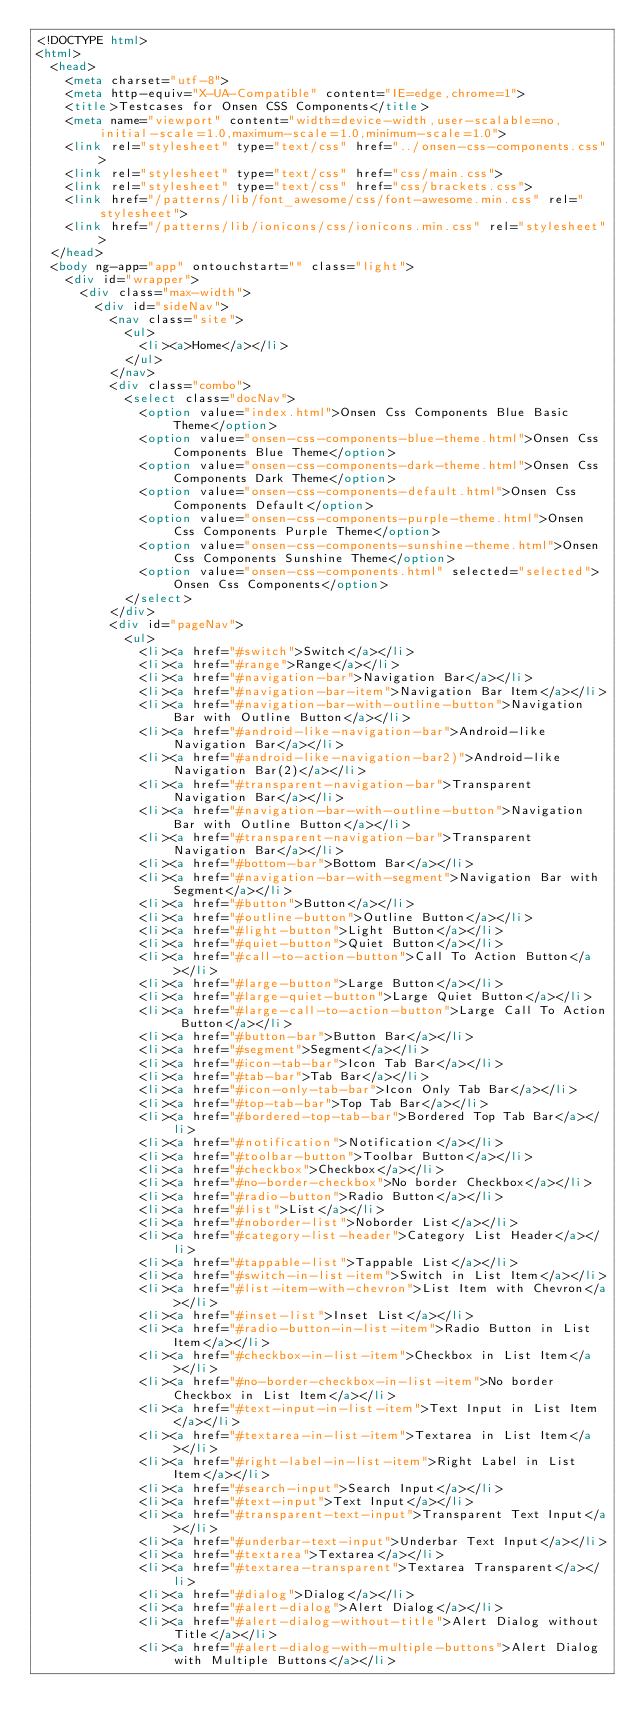<code> <loc_0><loc_0><loc_500><loc_500><_HTML_><!DOCTYPE html>
<html>
  <head>
    <meta charset="utf-8">
    <meta http-equiv="X-UA-Compatible" content="IE=edge,chrome=1">
    <title>Testcases for Onsen CSS Components</title>
    <meta name="viewport" content="width=device-width,user-scalable=no,initial-scale=1.0,maximum-scale=1.0,minimum-scale=1.0">
    <link rel="stylesheet" type="text/css" href="../onsen-css-components.css">
    <link rel="stylesheet" type="text/css" href="css/main.css">
    <link rel="stylesheet" type="text/css" href="css/brackets.css">
    <link href="/patterns/lib/font_awesome/css/font-awesome.min.css" rel="stylesheet">
    <link href="/patterns/lib/ionicons/css/ionicons.min.css" rel="stylesheet">
  </head>
  <body ng-app="app" ontouchstart="" class="light">
    <div id="wrapper">
      <div class="max-width">
        <div id="sideNav">
          <nav class="site">
            <ul>
              <li><a>Home</a></li>
            </ul>
          </nav>
          <div class="combo">
            <select class="docNav">
              <option value="index.html">Onsen Css Components Blue Basic Theme</option>
              <option value="onsen-css-components-blue-theme.html">Onsen Css Components Blue Theme</option>
              <option value="onsen-css-components-dark-theme.html">Onsen Css Components Dark Theme</option>
              <option value="onsen-css-components-default.html">Onsen Css Components Default</option>
              <option value="onsen-css-components-purple-theme.html">Onsen Css Components Purple Theme</option>
              <option value="onsen-css-components-sunshine-theme.html">Onsen Css Components Sunshine Theme</option>
              <option value="onsen-css-components.html" selected="selected">Onsen Css Components</option>
            </select>
          </div>
          <div id="pageNav">
            <ul>
              <li><a href="#switch">Switch</a></li>
              <li><a href="#range">Range</a></li>
              <li><a href="#navigation-bar">Navigation Bar</a></li>
              <li><a href="#navigation-bar-item">Navigation Bar Item</a></li>
              <li><a href="#navigation-bar-with-outline-button">Navigation Bar with Outline Button</a></li>
              <li><a href="#android-like-navigation-bar">Android-like Navigation Bar</a></li>
              <li><a href="#android-like-navigation-bar2)">Android-like Navigation Bar(2)</a></li>
              <li><a href="#transparent-navigation-bar">Transparent Navigation Bar</a></li>
              <li><a href="#navigation-bar-with-outline-button">Navigation Bar with Outline Button</a></li>
              <li><a href="#transparent-navigation-bar">Transparent Navigation Bar</a></li>
              <li><a href="#bottom-bar">Bottom Bar</a></li>
              <li><a href="#navigation-bar-with-segment">Navigation Bar with Segment</a></li>
              <li><a href="#button">Button</a></li>
              <li><a href="#outline-button">Outline Button</a></li>
              <li><a href="#light-button">Light Button</a></li>
              <li><a href="#quiet-button">Quiet Button</a></li>
              <li><a href="#call-to-action-button">Call To Action Button</a></li>
              <li><a href="#large-button">Large Button</a></li>
              <li><a href="#large-quiet-button">Large Quiet Button</a></li>
              <li><a href="#large-call-to-action-button">Large Call To Action Button</a></li>
              <li><a href="#button-bar">Button Bar</a></li>
              <li><a href="#segment">Segment</a></li>
              <li><a href="#icon-tab-bar">Icon Tab Bar</a></li>
              <li><a href="#tab-bar">Tab Bar</a></li>
              <li><a href="#icon-only-tab-bar">Icon Only Tab Bar</a></li>
              <li><a href="#top-tab-bar">Top Tab Bar</a></li>
              <li><a href="#bordered-top-tab-bar">Bordered Top Tab Bar</a></li>
              <li><a href="#notification">Notification</a></li>
              <li><a href="#toolbar-button">Toolbar Button</a></li>
              <li><a href="#checkbox">Checkbox</a></li>
              <li><a href="#no-border-checkbox">No border Checkbox</a></li>
              <li><a href="#radio-button">Radio Button</a></li>
              <li><a href="#list">List</a></li>
              <li><a href="#noborder-list">Noborder List</a></li>
              <li><a href="#category-list-header">Category List Header</a></li>
              <li><a href="#tappable-list">Tappable List</a></li>
              <li><a href="#switch-in-list-item">Switch in List Item</a></li>
              <li><a href="#list-item-with-chevron">List Item with Chevron</a></li>
              <li><a href="#inset-list">Inset List</a></li>
              <li><a href="#radio-button-in-list-item">Radio Button in List Item</a></li>
              <li><a href="#checkbox-in-list-item">Checkbox in List Item</a></li>
              <li><a href="#no-border-checkbox-in-list-item">No border Checkbox in List Item</a></li>
              <li><a href="#text-input-in-list-item">Text Input in List Item</a></li>
              <li><a href="#textarea-in-list-item">Textarea in List Item</a></li>
              <li><a href="#right-label-in-list-item">Right Label in List Item</a></li>
              <li><a href="#search-input">Search Input</a></li>
              <li><a href="#text-input">Text Input</a></li>
              <li><a href="#transparent-text-input">Transparent Text Input</a></li>
              <li><a href="#underbar-text-input">Underbar Text Input</a></li>
              <li><a href="#textarea">Textarea</a></li>
              <li><a href="#textarea-transparent">Textarea Transparent</a></li>
              <li><a href="#dialog">Dialog</a></li>
              <li><a href="#alert-dialog">Alert Dialog</a></li>
              <li><a href="#alert-dialog-without-title">Alert Dialog without Title</a></li>
              <li><a href="#alert-dialog-with-multiple-buttons">Alert Dialog with Multiple Buttons</a></li></code> 